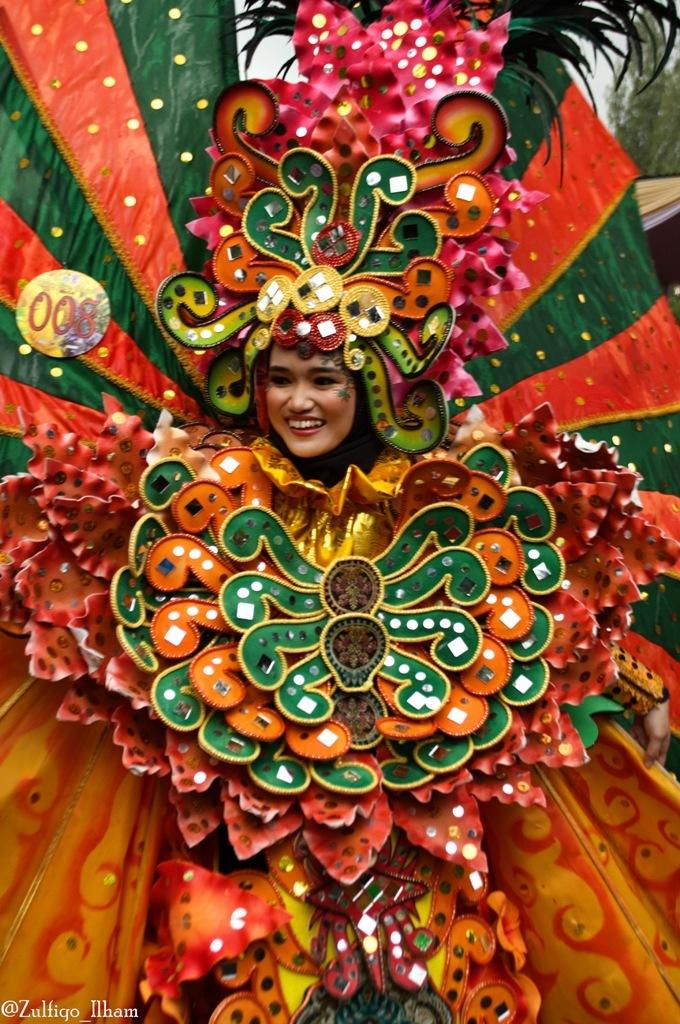Who is the main subject in the image? There is a lady in the center of the image. What is the lady wearing? The lady is wearing a costume. What expression does the lady have? The lady is smiling. What type of decision is the lady making in the image? There is no indication in the image that the lady is making a decision. What hobbies does the lady enjoy, as seen in the image? The image does not provide information about the lady's hobbies. 